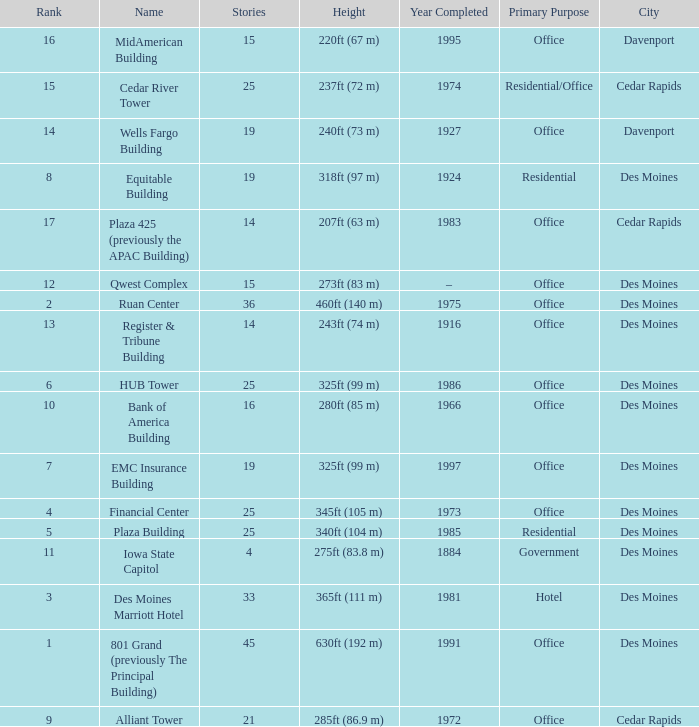What is the height of the EMC Insurance Building in Des Moines? 325ft (99 m). 